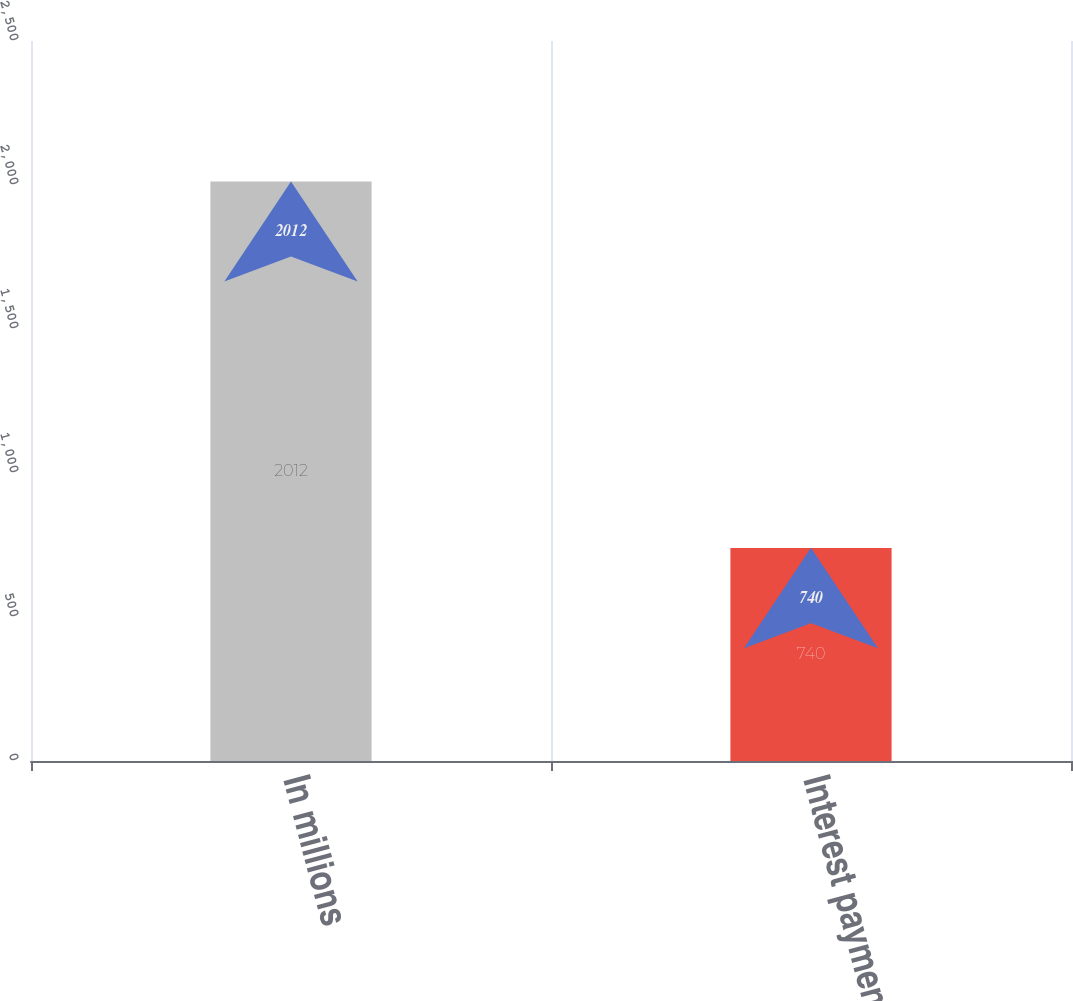<chart> <loc_0><loc_0><loc_500><loc_500><bar_chart><fcel>In millions<fcel>Interest payments<nl><fcel>2012<fcel>740<nl></chart> 